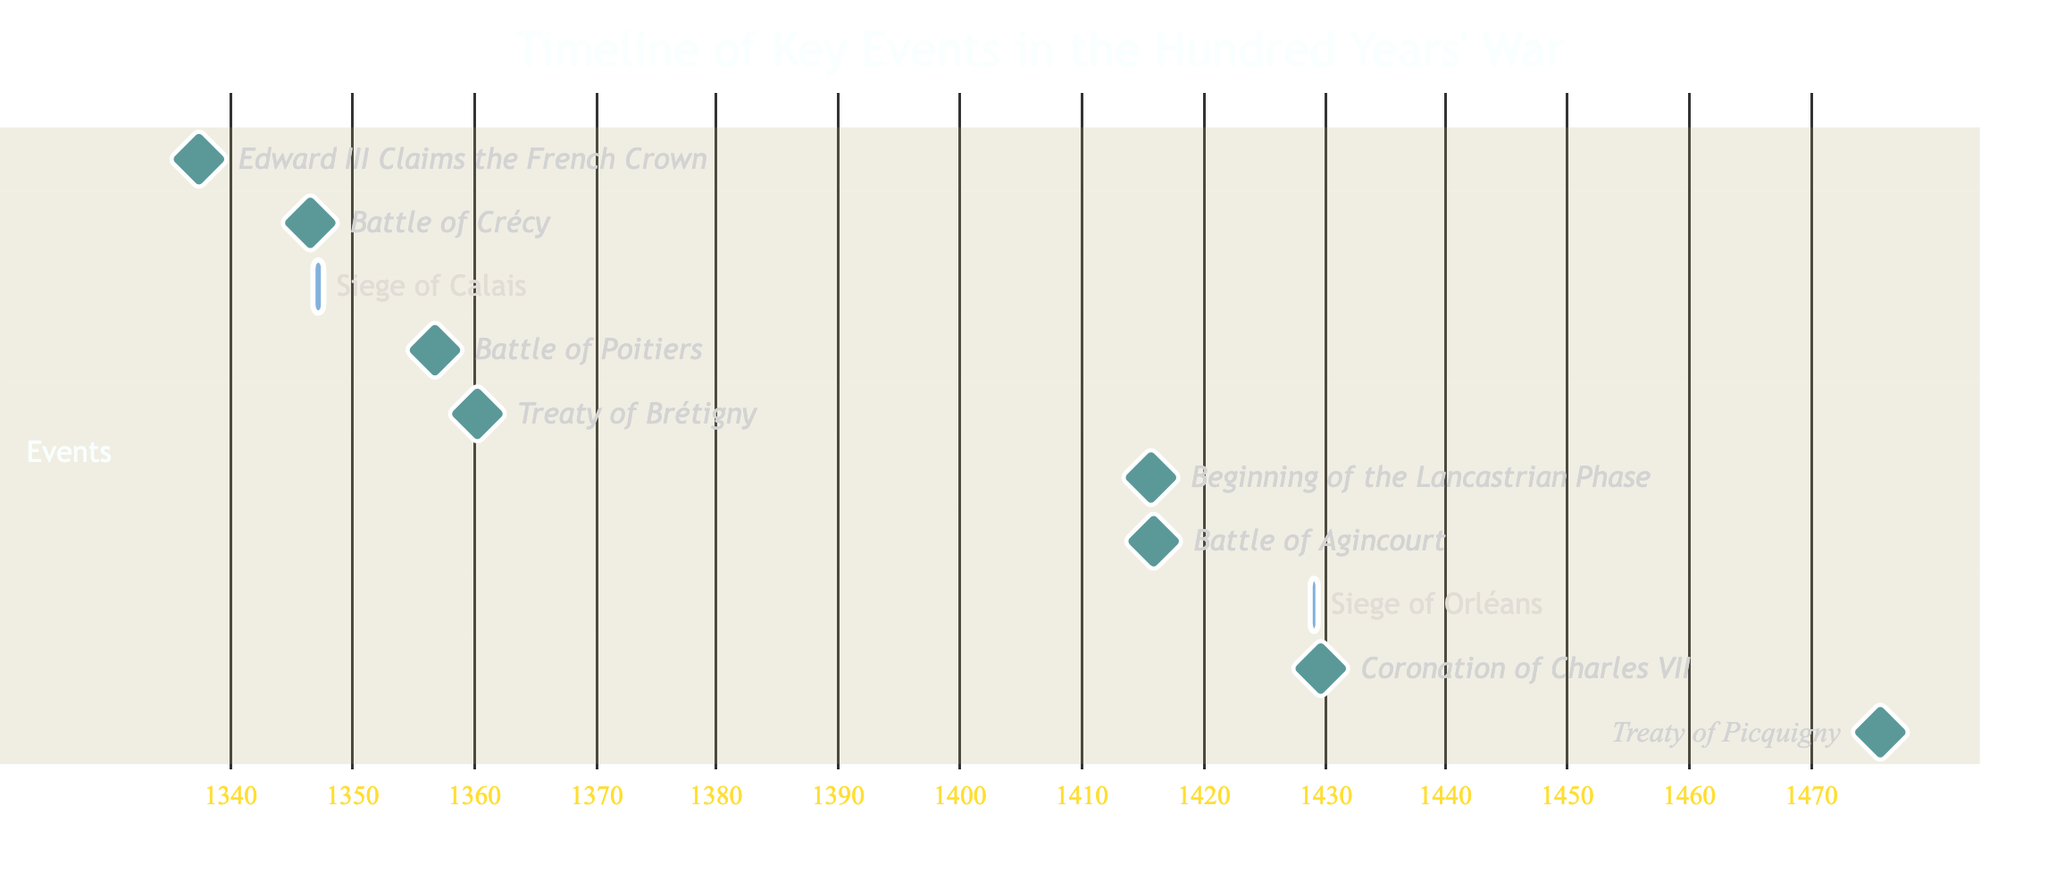What is the first event listed in the timeline? The first event in the timeline is "Edward III Claims the French Crown", appearing at the top of the Gantt Chart.
Answer: Edward III Claims the French Crown Which event occurred immediately after the Battle of Crécy? Following the Battle of Crécy, the next event in the timeline is the "Siege of Calais", which appears directly below it.
Answer: Siege of Calais How many events were marked as milestones? By counting the events marked distinctly in the Gantt Chart as milestones, there are a total of seven events categorized this way.
Answer: 7 What year did the Siege of Orléans begin? According to the timeline, the Siege of Orléans began in the year 1428, which is indicated in its starting date on the Gantt Chart.
Answer: 1428 What is the duration of the Siege of Calais? The duration of the Siege of Calais can be calculated from its start date of September 4, 1346, to the end date of August 3, 1347, which is a span of nearly 11 months.
Answer: 11 months Which event has the latest date in the timeline? The event marked with the latest date in the timeline is the "Treaty of Picquigny", which occurred on August 29, 1475, the last date shown on the Gantt Chart.
Answer: Treaty of Picquigny In what year did Charles VII get coronated? The Gantt Chart indicates that the coronation of Charles VII took place in the year 1429, as marked on the timeline.
Answer: 1429 How long did the Lancastrian Phase last, as indicated in the chart? Since the Lancastrian Phase begins on August 15, 1415, and is marked as a milestone with no indicated end date, it suggests a continuing phase starting from that date, marking it as ongoing.
Answer: Ongoing What event occurred immediately before the Treaty of Brétigny? The event that occurred immediately before Treaty of Brétigny is the Battle of Poitiers, which is shown directly above it in the timeline sequence.
Answer: Battle of Poitiers 